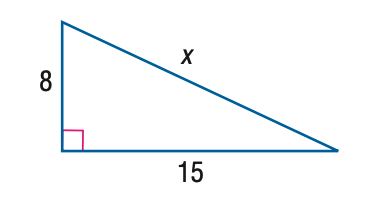Answer the mathemtical geometry problem and directly provide the correct option letter.
Question: Find x.
Choices: A: 8 B: 12.7 C: 15 D: 17 D 